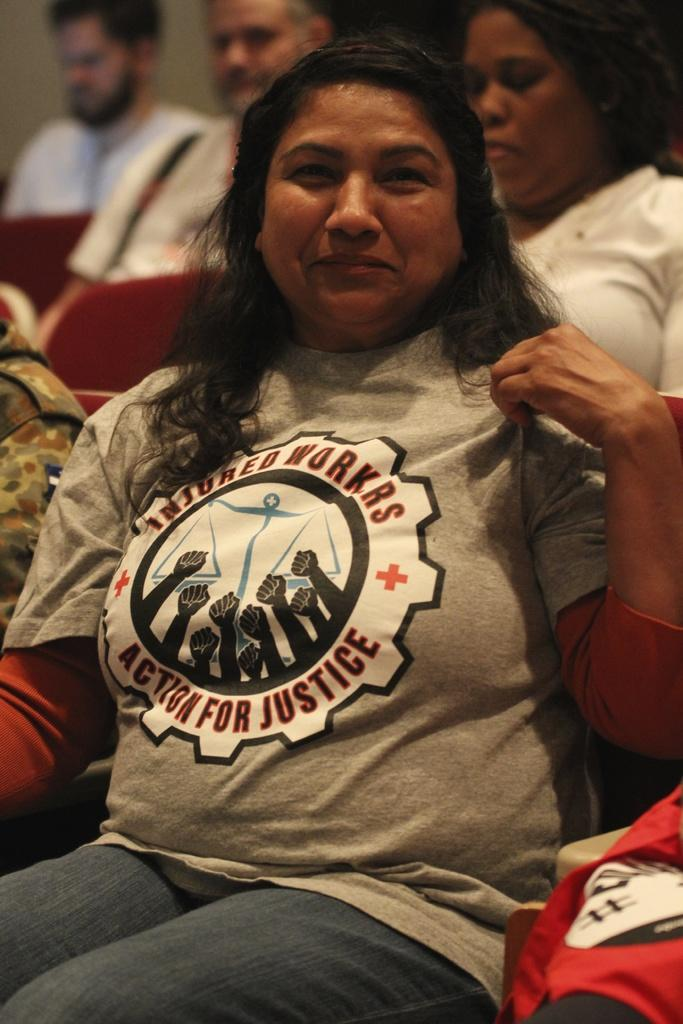<image>
Create a compact narrative representing the image presented. Woman wearing a shirt which says Action For Justice on it. 